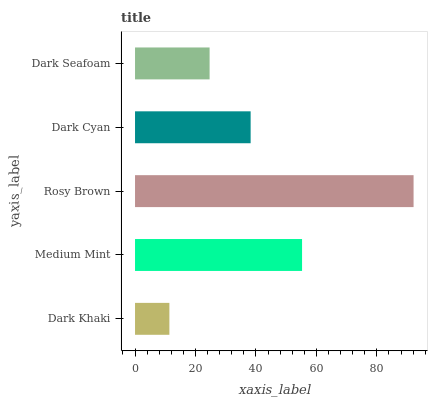Is Dark Khaki the minimum?
Answer yes or no. Yes. Is Rosy Brown the maximum?
Answer yes or no. Yes. Is Medium Mint the minimum?
Answer yes or no. No. Is Medium Mint the maximum?
Answer yes or no. No. Is Medium Mint greater than Dark Khaki?
Answer yes or no. Yes. Is Dark Khaki less than Medium Mint?
Answer yes or no. Yes. Is Dark Khaki greater than Medium Mint?
Answer yes or no. No. Is Medium Mint less than Dark Khaki?
Answer yes or no. No. Is Dark Cyan the high median?
Answer yes or no. Yes. Is Dark Cyan the low median?
Answer yes or no. Yes. Is Rosy Brown the high median?
Answer yes or no. No. Is Dark Khaki the low median?
Answer yes or no. No. 